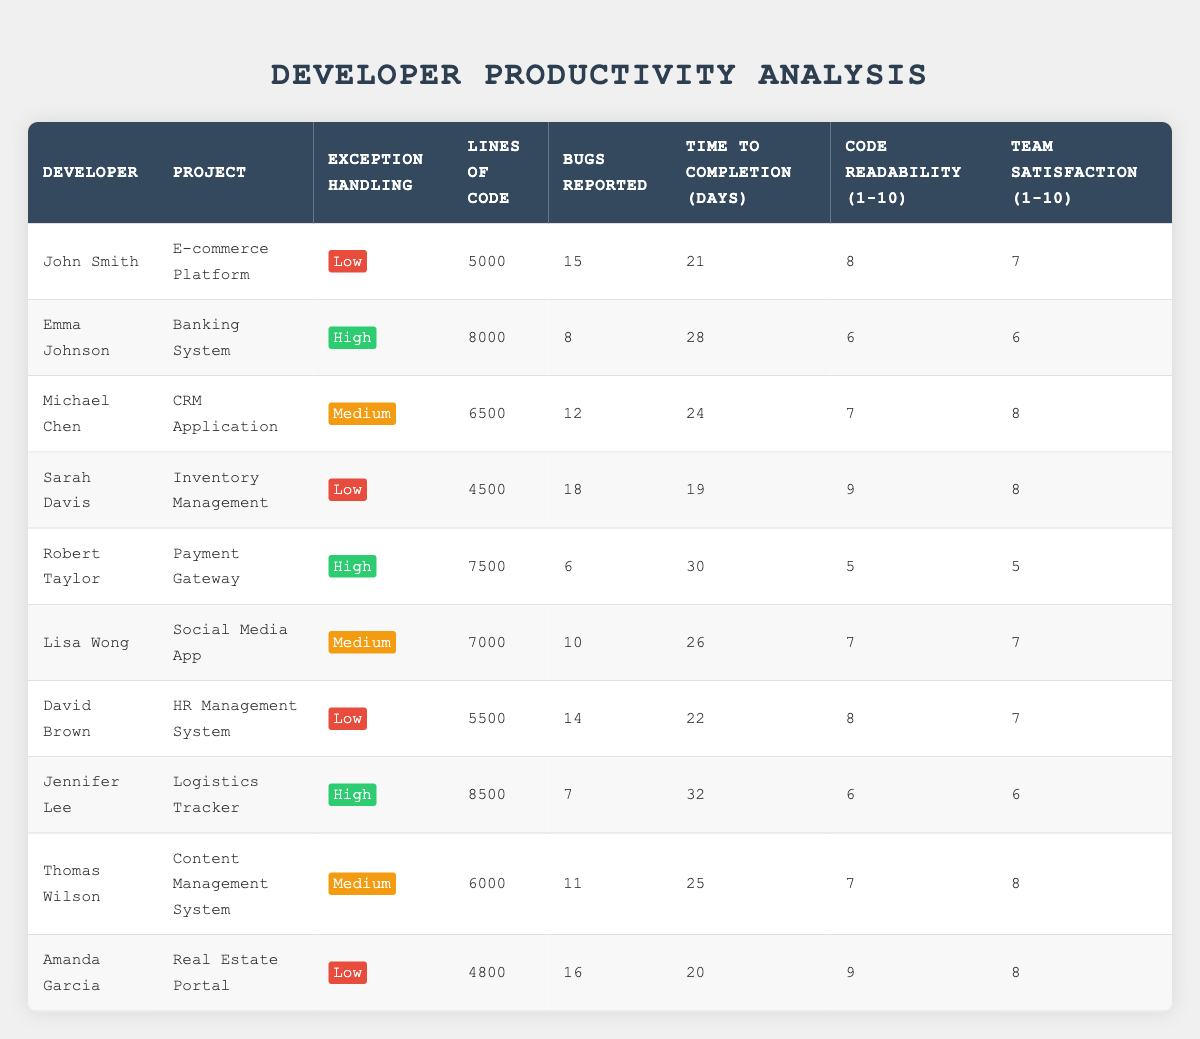What is the average time to completion for developers with high exception handling? There are two developers with high exception handling: Emma Johnson (28 days) and Robert Taylor (30 days). The sum of their completion times is 28 + 30 = 58 days. Since there are 2 developers, the average is 58/2 = 29 days.
Answer: 29 days How many bugs were reported by developers with low exception handling? There are three developers with low exception handling: John Smith (15 bugs), Sarah Davis (18 bugs), and David Brown (14 bugs). The total number of bugs reported is 15 + 18 + 14 = 47 bugs.
Answer: 47 bugs Which developer reported the fewest number of bugs, and what was that number? By examining the 'Bugs Reported' column, Robert Taylor reported 6 bugs, which is less than any others listed in the table.
Answer: Robert Taylor, 6 bugs Is it true that Amanda Garcia has the highest code readability score among all developers? Amanda Garcia has a code readability score of 9, which is the highest compared to others in the table. Therefore, the statement is true.
Answer: Yes What is the total number of lines of code for developers with medium exception handling? The developers with medium exception handling are Michael Chen (6500 lines), Lisa Wong (7000 lines), and Thomas Wilson (6000 lines). The total number of lines of code is 6500 + 7000 + 6000 = 19500 lines.
Answer: 19500 lines What is the median time to completion for all developers? Listing the time to completion in ascending order gives us: 19, 20, 21, 22, 24, 25, 26, 28, 30, 32. There are 10 data points, and the median is the average of the 5th and 6th values: (24 + 25)/2 = 24.5 days.
Answer: 24.5 days Who among the developers with high exception handling has the most lines of code? Evaluating the developers with high exception handling, Emma Johnson has 8000 lines and Robert Taylor has 7500. Emma Johnson reported the most lines of code at 8000.
Answer: Emma Johnson, 8000 lines What is the average team satisfaction score for developers with low exception handling? The developers with low exception handling are John Smith (7), Sarah Davis (8), and David Brown (7). The total satisfaction score is 7 + 8 + 7 = 22. The average is 22/3 = 7.33 (or rounded to 7 when looking at whole numbers).
Answer: 7.33 (or 7 when rounded) Which project had the longest time to completion, and how many days did it take? Reviewing the 'Time to Completion' column, the longest time is recorded for Jennifer Lee's project, the Logistics Tracker, which took 32 days.
Answer: Logistics Tracker, 32 days 